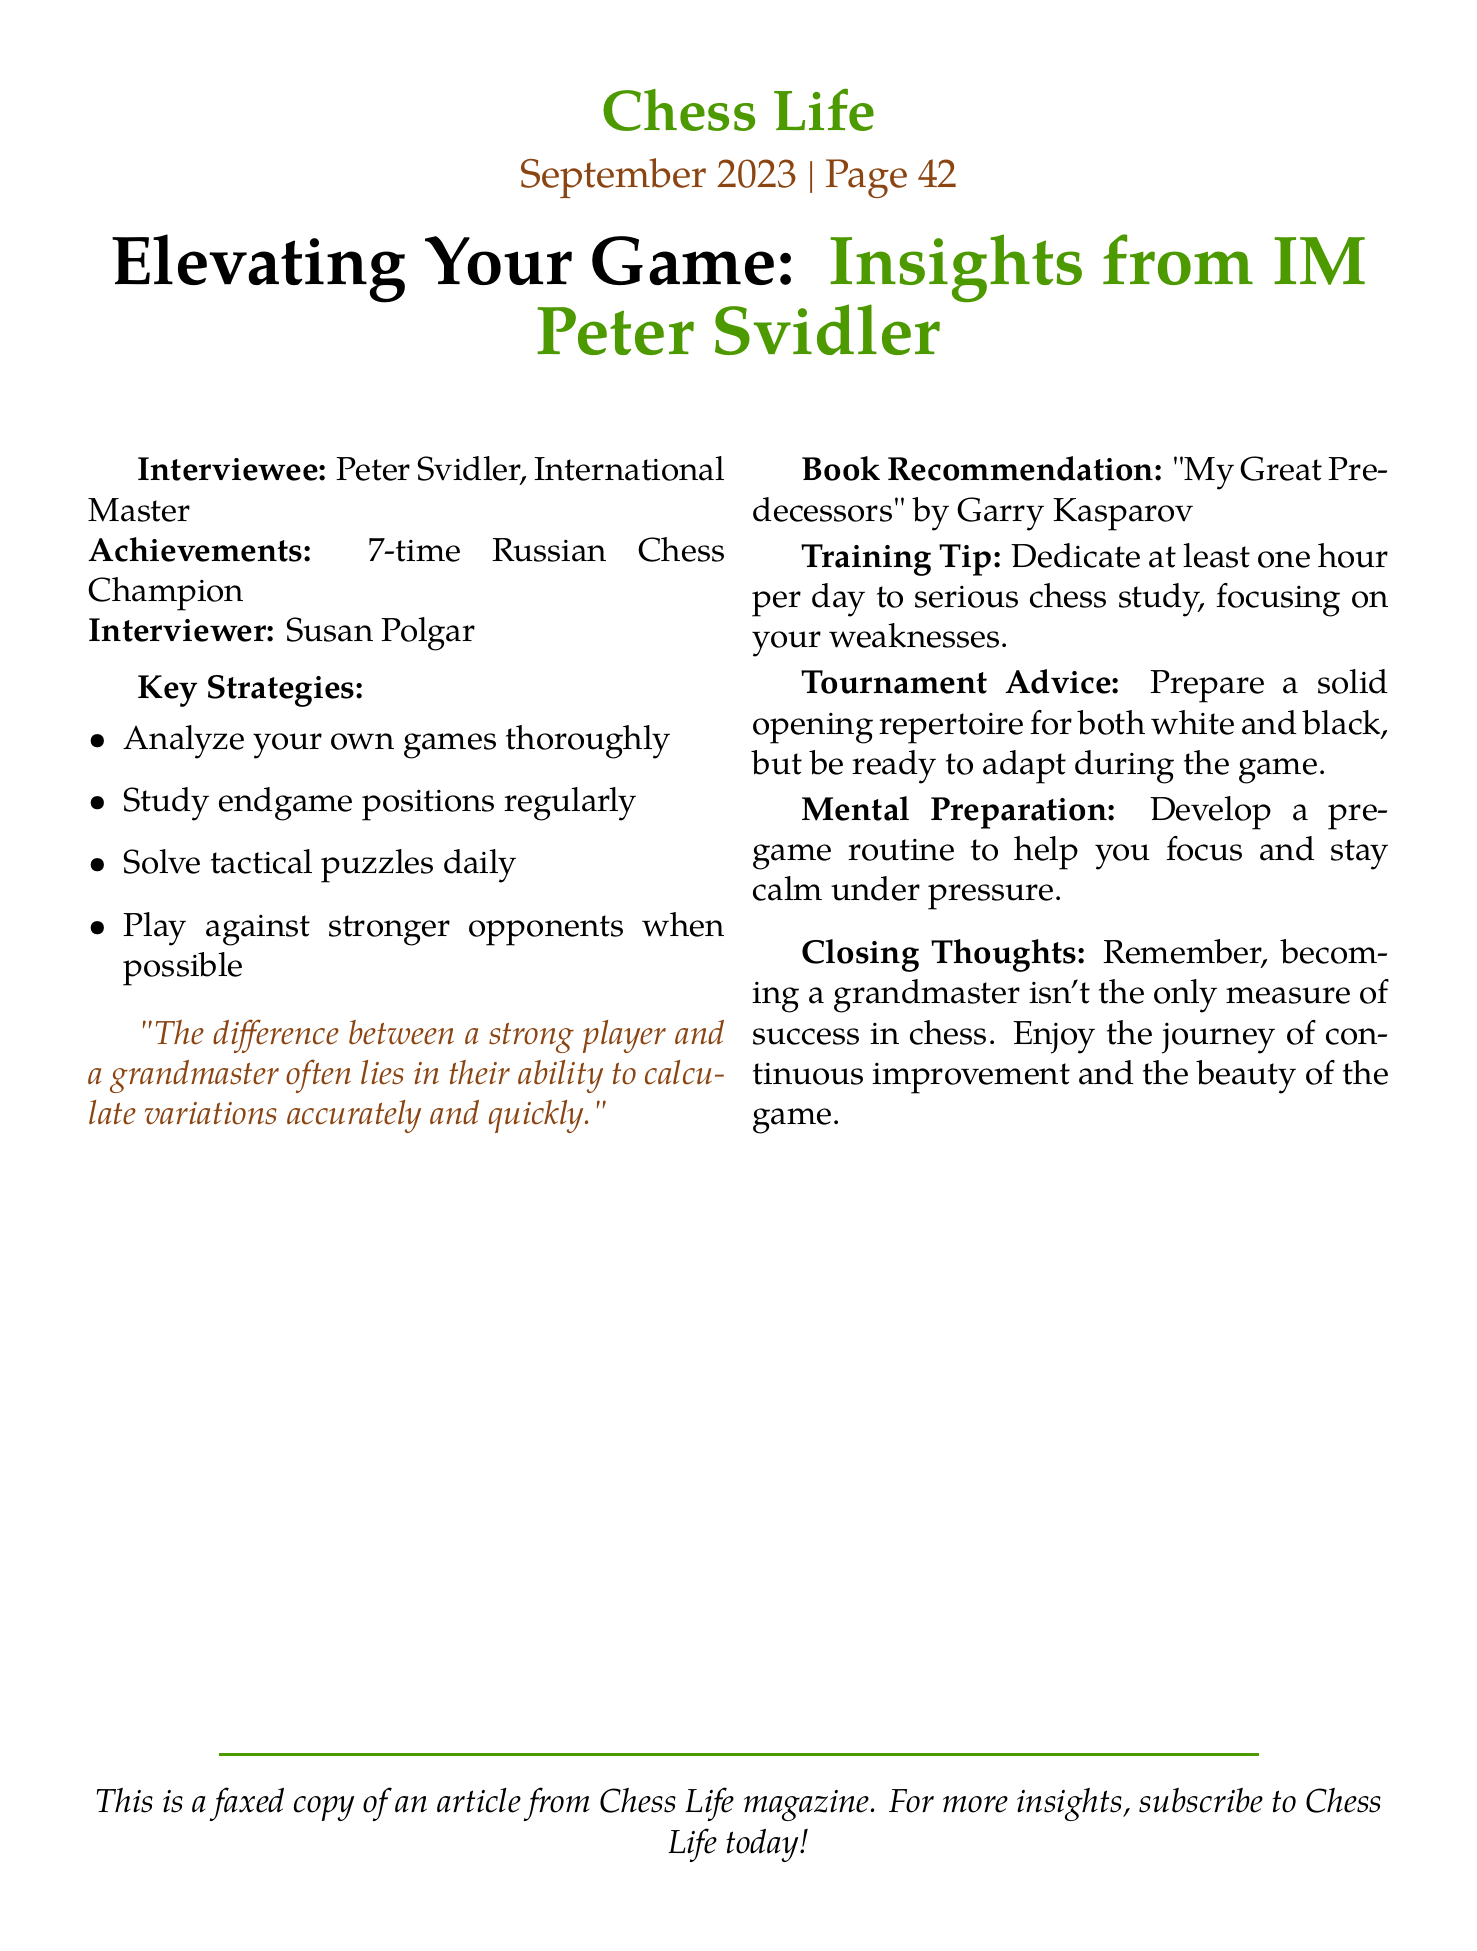What is the title of the article? The title is indicated at the top of the document and reads "Elevating Your Game: Insights from IM Peter Svidler."
Answer: Elevating Your Game: Insights from IM Peter Svidler Who is the interviewer? The interviewer is mentioned near the beginning of the document alongside the interviewee's name and is Susan Polgar.
Answer: Susan Polgar How many times has Peter Svidler won the Russian Chess Championship? This information is provided under the interviewee's achievements and states he has won it 7 times.
Answer: 7-time What is Peter Svidler's training tip? The training tip is given in the section outlining key insights and suggests dedicating one hour per day to serious chess study.
Answer: Dedicate at least one hour per day to serious chess study Which book does Peter Svidler recommend? The book recommendation is clearly stated in the document and is "My Great Predecessors" by Garry Kasparov.
Answer: My Great Predecessors by Garry Kasparov What is one of the key strategies mentioned? One of the key strategies provided in the itemized list is to "Analyze your own games thoroughly."
Answer: Analyze your own games thoroughly What is a significant factor distinguishing a strong player from a grandmaster according to the interview? This distinction is highlighted in a quote within the document discussing the ability to calculate variations.
Answer: Ability to calculate variations What does the document refer to? The text at the bottom indicates it is a faxed copy of an article.
Answer: A faxed copy of an article 